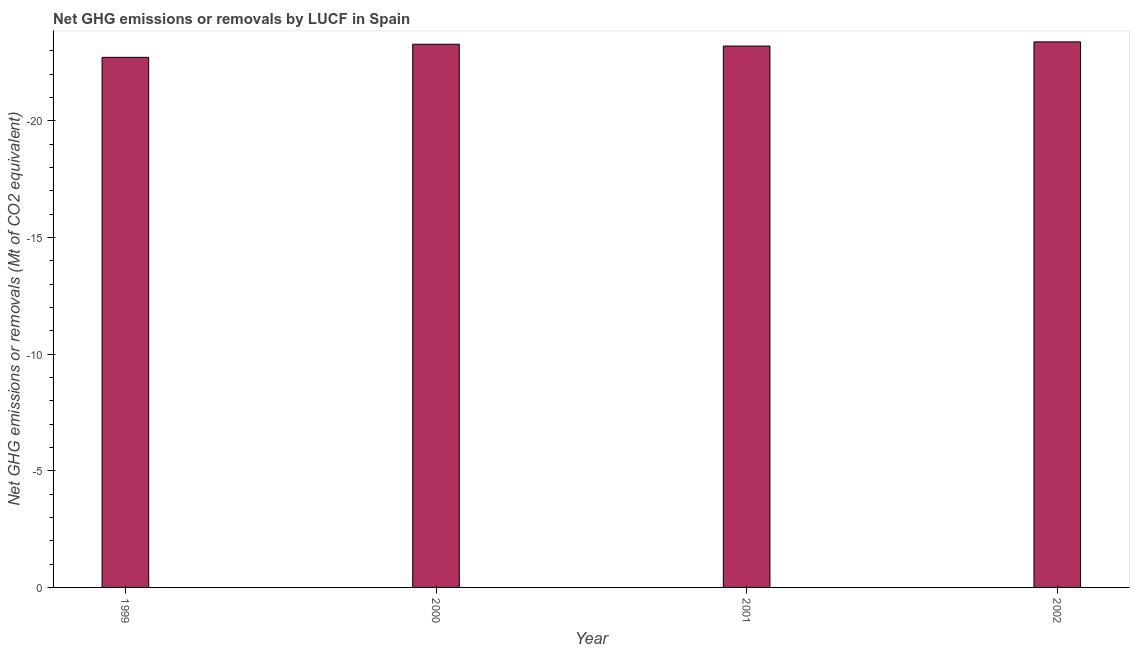Does the graph contain any zero values?
Give a very brief answer. Yes. What is the title of the graph?
Provide a succinct answer. Net GHG emissions or removals by LUCF in Spain. What is the label or title of the Y-axis?
Your answer should be compact. Net GHG emissions or removals (Mt of CO2 equivalent). What is the ghg net emissions or removals in 2001?
Your answer should be compact. 0. Across all years, what is the minimum ghg net emissions or removals?
Your answer should be very brief. 0. What is the average ghg net emissions or removals per year?
Provide a succinct answer. 0. In how many years, is the ghg net emissions or removals greater than -13 Mt?
Give a very brief answer. 0. In how many years, is the ghg net emissions or removals greater than the average ghg net emissions or removals taken over all years?
Keep it short and to the point. 0. How many years are there in the graph?
Your response must be concise. 4. What is the Net GHG emissions or removals (Mt of CO2 equivalent) of 2002?
Offer a very short reply. 0. 